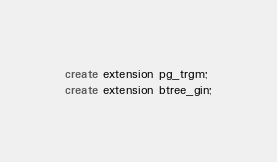<code> <loc_0><loc_0><loc_500><loc_500><_SQL_>create extension pg_trgm;
create extension btree_gin;</code> 